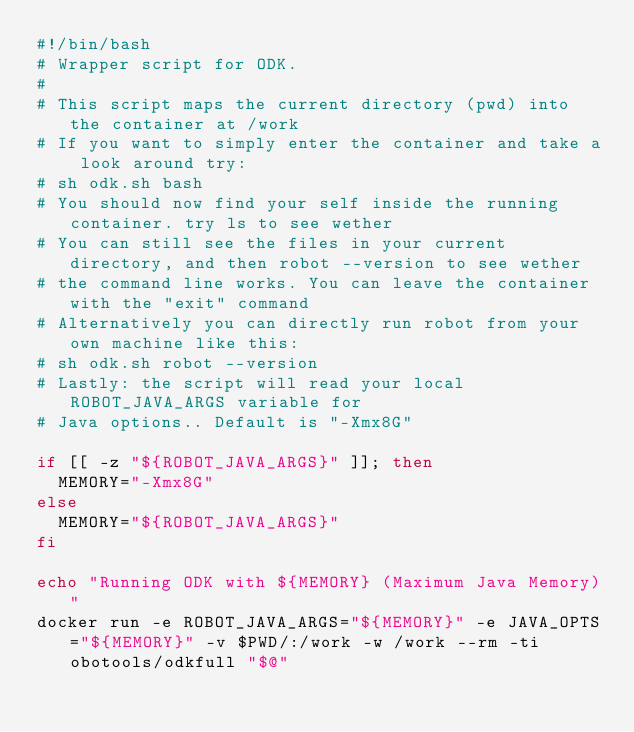Convert code to text. <code><loc_0><loc_0><loc_500><loc_500><_Bash_>#!/bin/bash
# Wrapper script for ODK.
#
# This script maps the current directory (pwd) into the container at /work
# If you want to simply enter the container and take a look around try:
# sh odk.sh bash
# You should now find your self inside the running container. try ls to see wether
# You can still see the files in your current directory, and then robot --version to see wether
# the command line works. You can leave the container with the "exit" command
# Alternatively you can directly run robot from your own machine like this:
# sh odk.sh robot --version
# Lastly: the script will read your local ROBOT_JAVA_ARGS variable for
# Java options.. Default is "-Xmx8G"

if [[ -z "${ROBOT_JAVA_ARGS}" ]]; then
  MEMORY="-Xmx8G"
else
  MEMORY="${ROBOT_JAVA_ARGS}"
fi

echo "Running ODK with ${MEMORY} (Maximum Java Memory)"
docker run -e ROBOT_JAVA_ARGS="${MEMORY}" -e JAVA_OPTS="${MEMORY}" -v $PWD/:/work -w /work --rm -ti obotools/odkfull "$@"
</code> 